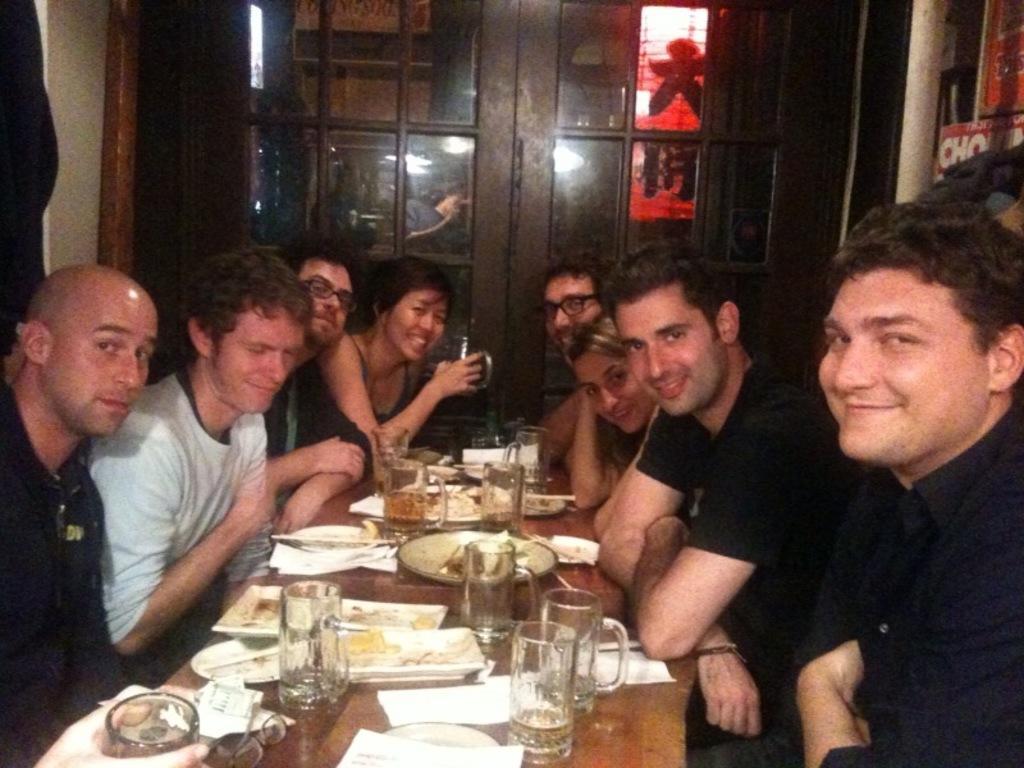In one or two sentences, can you explain what this image depicts? As we can see in the image there is a wall, door, group of people sitting on chairs and there is a table. On table there are glasses, plates, different types of dishes and tissues. 